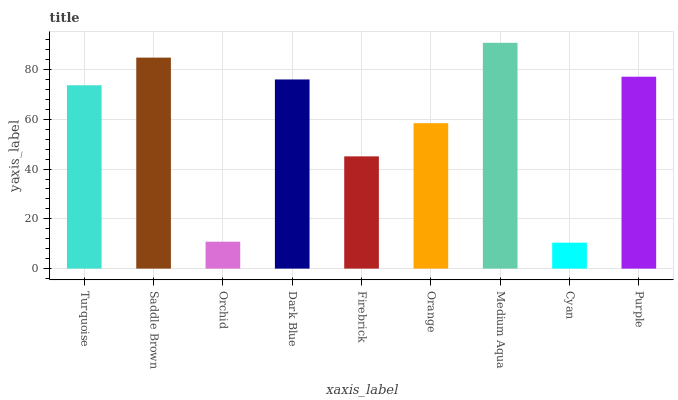Is Cyan the minimum?
Answer yes or no. Yes. Is Medium Aqua the maximum?
Answer yes or no. Yes. Is Saddle Brown the minimum?
Answer yes or no. No. Is Saddle Brown the maximum?
Answer yes or no. No. Is Saddle Brown greater than Turquoise?
Answer yes or no. Yes. Is Turquoise less than Saddle Brown?
Answer yes or no. Yes. Is Turquoise greater than Saddle Brown?
Answer yes or no. No. Is Saddle Brown less than Turquoise?
Answer yes or no. No. Is Turquoise the high median?
Answer yes or no. Yes. Is Turquoise the low median?
Answer yes or no. Yes. Is Orchid the high median?
Answer yes or no. No. Is Medium Aqua the low median?
Answer yes or no. No. 